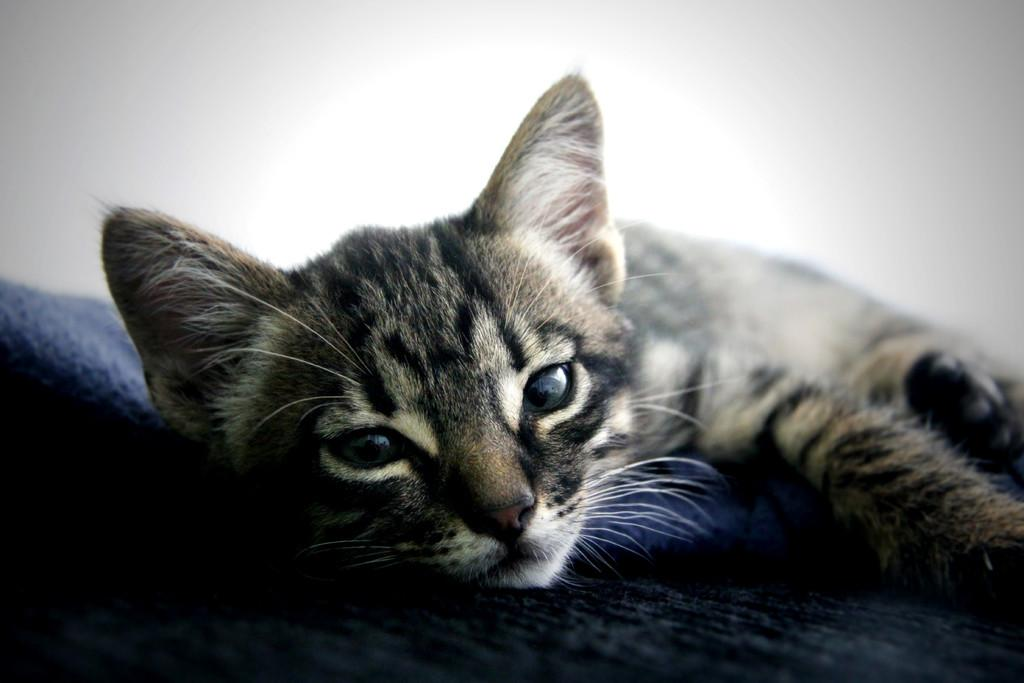What type of animal is in the image? There is a cat in the image. What might the cat be doing in the image? The cat might be sleeping on a bed. What can be seen in the background of the image? There is a wall visible in the background of the image. What type of smell can be detected coming from the cat in the image? There is no indication of any smell in the image, as it is a static representation of the cat. 